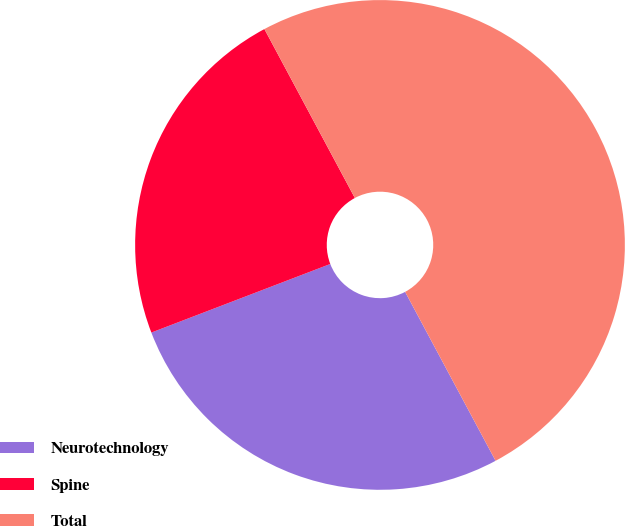Convert chart to OTSL. <chart><loc_0><loc_0><loc_500><loc_500><pie_chart><fcel>Neurotechnology<fcel>Spine<fcel>Total<nl><fcel>27.0%<fcel>23.0%<fcel>50.0%<nl></chart> 